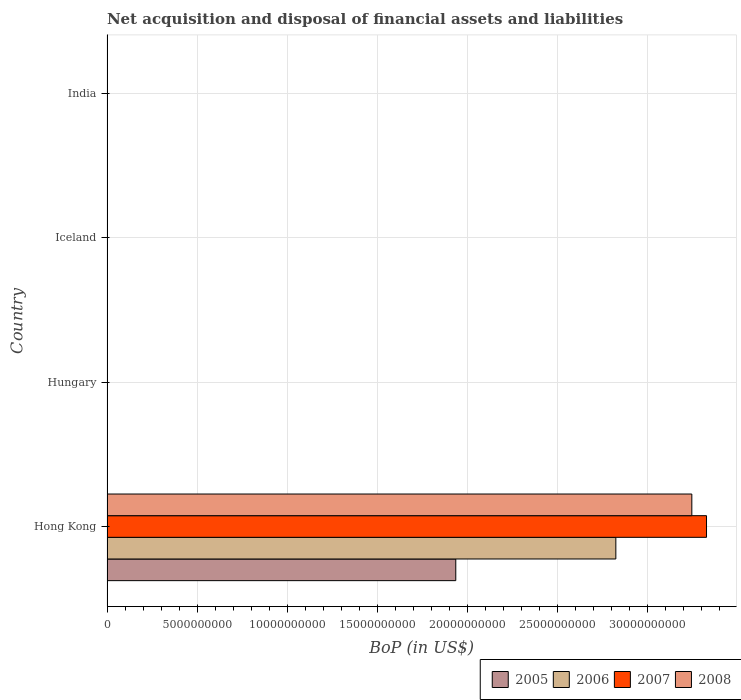How many different coloured bars are there?
Offer a very short reply. 4. Are the number of bars per tick equal to the number of legend labels?
Your answer should be very brief. No. Are the number of bars on each tick of the Y-axis equal?
Make the answer very short. No. How many bars are there on the 1st tick from the bottom?
Your response must be concise. 4. What is the label of the 3rd group of bars from the top?
Your answer should be very brief. Hungary. In how many cases, is the number of bars for a given country not equal to the number of legend labels?
Your answer should be very brief. 3. Across all countries, what is the maximum Balance of Payments in 2007?
Provide a succinct answer. 3.33e+1. Across all countries, what is the minimum Balance of Payments in 2007?
Ensure brevity in your answer.  0. In which country was the Balance of Payments in 2006 maximum?
Your answer should be compact. Hong Kong. What is the total Balance of Payments in 2008 in the graph?
Provide a succinct answer. 3.25e+1. What is the difference between the Balance of Payments in 2006 in India and the Balance of Payments in 2005 in Hong Kong?
Your answer should be compact. -1.94e+1. What is the average Balance of Payments in 2007 per country?
Give a very brief answer. 8.32e+09. What is the difference between the Balance of Payments in 2008 and Balance of Payments in 2006 in Hong Kong?
Give a very brief answer. 4.22e+09. In how many countries, is the Balance of Payments in 2005 greater than 1000000000 US$?
Give a very brief answer. 1. What is the difference between the highest and the lowest Balance of Payments in 2005?
Your answer should be compact. 1.94e+1. In how many countries, is the Balance of Payments in 2008 greater than the average Balance of Payments in 2008 taken over all countries?
Keep it short and to the point. 1. Are all the bars in the graph horizontal?
Offer a terse response. Yes. What is the difference between two consecutive major ticks on the X-axis?
Keep it short and to the point. 5.00e+09. Does the graph contain grids?
Give a very brief answer. Yes. Where does the legend appear in the graph?
Your answer should be very brief. Bottom right. What is the title of the graph?
Keep it short and to the point. Net acquisition and disposal of financial assets and liabilities. What is the label or title of the X-axis?
Keep it short and to the point. BoP (in US$). What is the BoP (in US$) in 2005 in Hong Kong?
Keep it short and to the point. 1.94e+1. What is the BoP (in US$) in 2006 in Hong Kong?
Your response must be concise. 2.83e+1. What is the BoP (in US$) in 2007 in Hong Kong?
Make the answer very short. 3.33e+1. What is the BoP (in US$) of 2008 in Hong Kong?
Your answer should be very brief. 3.25e+1. What is the BoP (in US$) in 2005 in Hungary?
Keep it short and to the point. 0. What is the BoP (in US$) of 2007 in Hungary?
Your answer should be compact. 0. What is the BoP (in US$) in 2008 in Hungary?
Offer a terse response. 0. What is the BoP (in US$) of 2005 in Iceland?
Give a very brief answer. 0. What is the BoP (in US$) in 2006 in Iceland?
Provide a short and direct response. 0. What is the BoP (in US$) in 2005 in India?
Provide a short and direct response. 0. What is the BoP (in US$) of 2006 in India?
Give a very brief answer. 0. Across all countries, what is the maximum BoP (in US$) of 2005?
Provide a short and direct response. 1.94e+1. Across all countries, what is the maximum BoP (in US$) in 2006?
Your response must be concise. 2.83e+1. Across all countries, what is the maximum BoP (in US$) of 2007?
Your answer should be compact. 3.33e+1. Across all countries, what is the maximum BoP (in US$) of 2008?
Make the answer very short. 3.25e+1. Across all countries, what is the minimum BoP (in US$) of 2005?
Give a very brief answer. 0. Across all countries, what is the minimum BoP (in US$) of 2007?
Your answer should be very brief. 0. Across all countries, what is the minimum BoP (in US$) of 2008?
Provide a short and direct response. 0. What is the total BoP (in US$) in 2005 in the graph?
Provide a short and direct response. 1.94e+1. What is the total BoP (in US$) of 2006 in the graph?
Provide a succinct answer. 2.83e+1. What is the total BoP (in US$) of 2007 in the graph?
Your answer should be compact. 3.33e+1. What is the total BoP (in US$) of 2008 in the graph?
Offer a very short reply. 3.25e+1. What is the average BoP (in US$) in 2005 per country?
Provide a short and direct response. 4.84e+09. What is the average BoP (in US$) in 2006 per country?
Provide a succinct answer. 7.06e+09. What is the average BoP (in US$) in 2007 per country?
Offer a very short reply. 8.32e+09. What is the average BoP (in US$) in 2008 per country?
Make the answer very short. 8.12e+09. What is the difference between the BoP (in US$) of 2005 and BoP (in US$) of 2006 in Hong Kong?
Offer a terse response. -8.89e+09. What is the difference between the BoP (in US$) in 2005 and BoP (in US$) in 2007 in Hong Kong?
Ensure brevity in your answer.  -1.39e+1. What is the difference between the BoP (in US$) in 2005 and BoP (in US$) in 2008 in Hong Kong?
Your answer should be compact. -1.31e+1. What is the difference between the BoP (in US$) in 2006 and BoP (in US$) in 2007 in Hong Kong?
Offer a very short reply. -5.04e+09. What is the difference between the BoP (in US$) of 2006 and BoP (in US$) of 2008 in Hong Kong?
Your answer should be compact. -4.22e+09. What is the difference between the BoP (in US$) of 2007 and BoP (in US$) of 2008 in Hong Kong?
Offer a very short reply. 8.15e+08. What is the difference between the highest and the lowest BoP (in US$) in 2005?
Your response must be concise. 1.94e+1. What is the difference between the highest and the lowest BoP (in US$) in 2006?
Keep it short and to the point. 2.83e+1. What is the difference between the highest and the lowest BoP (in US$) in 2007?
Your answer should be very brief. 3.33e+1. What is the difference between the highest and the lowest BoP (in US$) in 2008?
Make the answer very short. 3.25e+1. 